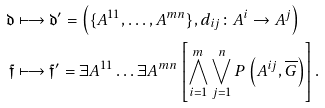<formula> <loc_0><loc_0><loc_500><loc_500>\mathfrak { d } & \longmapsto \mathfrak { d } ^ { \prime } = \left ( \{ A ^ { 1 1 } , \dots , A ^ { m n } \} , d _ { i j } \colon A ^ { i } \rightarrow A ^ { j } \right ) \\ \mathfrak { f } & \longmapsto \mathfrak { f } ^ { \prime } = \exists A ^ { 1 1 } \dots \exists A ^ { m n } \left [ \bigwedge ^ { m } _ { i = 1 } \bigvee _ { j = 1 } ^ { n } P \left ( A ^ { i j } , \overline { G } \right ) \right ] .</formula> 